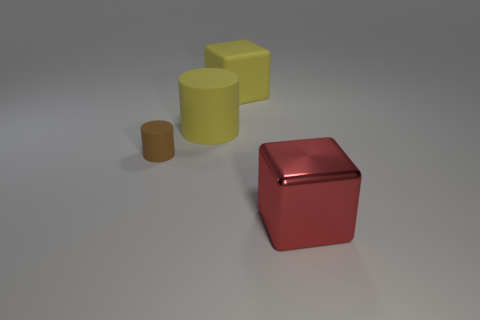Add 1 large yellow blocks. How many objects exist? 5 Subtract all green cubes. Subtract all yellow cylinders. How many cubes are left? 2 Subtract all small rubber things. Subtract all tiny brown matte objects. How many objects are left? 2 Add 1 red shiny objects. How many red shiny objects are left? 2 Add 1 big red blocks. How many big red blocks exist? 2 Subtract 0 yellow balls. How many objects are left? 4 Subtract 1 cylinders. How many cylinders are left? 1 